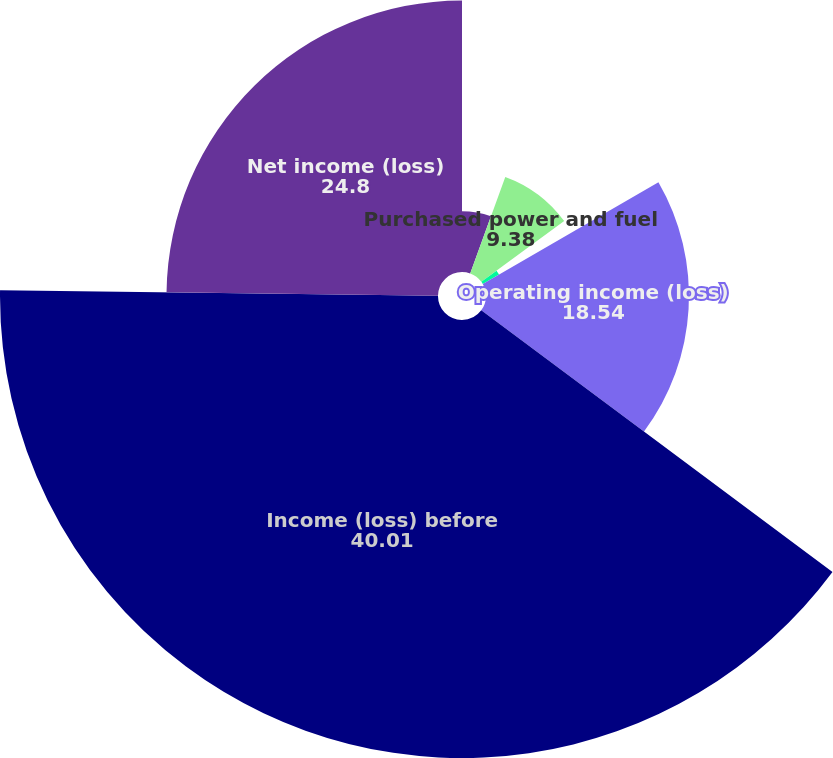Convert chart to OTSL. <chart><loc_0><loc_0><loc_500><loc_500><pie_chart><fcel>Operating revenues<fcel>Purchased power and fuel<fcel>Operating and maintenance<fcel>Operating income (loss)<fcel>Income (loss) before<fcel>Net income (loss)<nl><fcel>5.55%<fcel>9.38%<fcel>1.72%<fcel>18.54%<fcel>40.01%<fcel>24.8%<nl></chart> 